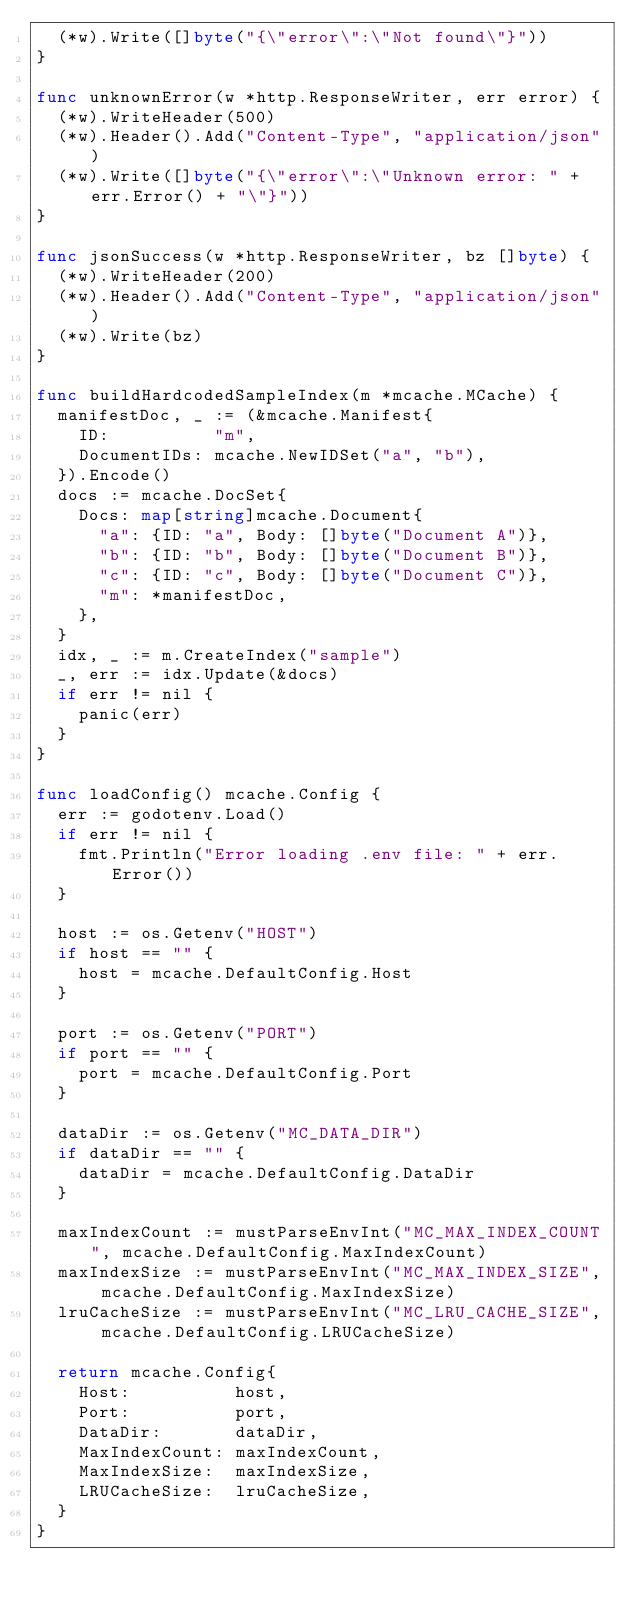<code> <loc_0><loc_0><loc_500><loc_500><_Go_>	(*w).Write([]byte("{\"error\":\"Not found\"}"))
}

func unknownError(w *http.ResponseWriter, err error) {
	(*w).WriteHeader(500)
	(*w).Header().Add("Content-Type", "application/json")
	(*w).Write([]byte("{\"error\":\"Unknown error: " + err.Error() + "\"}"))
}

func jsonSuccess(w *http.ResponseWriter, bz []byte) {
	(*w).WriteHeader(200)
	(*w).Header().Add("Content-Type", "application/json")
	(*w).Write(bz)
}

func buildHardcodedSampleIndex(m *mcache.MCache) {
	manifestDoc, _ := (&mcache.Manifest{
		ID:          "m",
		DocumentIDs: mcache.NewIDSet("a", "b"),
	}).Encode()
	docs := mcache.DocSet{
		Docs: map[string]mcache.Document{
			"a": {ID: "a", Body: []byte("Document A")},
			"b": {ID: "b", Body: []byte("Document B")},
			"c": {ID: "c", Body: []byte("Document C")},
			"m": *manifestDoc,
		},
	}
	idx, _ := m.CreateIndex("sample")
	_, err := idx.Update(&docs)
	if err != nil {
		panic(err)
	}
}

func loadConfig() mcache.Config {
	err := godotenv.Load()
	if err != nil {
		fmt.Println("Error loading .env file: " + err.Error())
	}

	host := os.Getenv("HOST")
	if host == "" {
		host = mcache.DefaultConfig.Host
	}

	port := os.Getenv("PORT")
	if port == "" {
		port = mcache.DefaultConfig.Port
	}

	dataDir := os.Getenv("MC_DATA_DIR")
	if dataDir == "" {
		dataDir = mcache.DefaultConfig.DataDir
	}

	maxIndexCount := mustParseEnvInt("MC_MAX_INDEX_COUNT", mcache.DefaultConfig.MaxIndexCount)
	maxIndexSize := mustParseEnvInt("MC_MAX_INDEX_SIZE", mcache.DefaultConfig.MaxIndexSize)
	lruCacheSize := mustParseEnvInt("MC_LRU_CACHE_SIZE", mcache.DefaultConfig.LRUCacheSize)

	return mcache.Config{
		Host:          host,
		Port:          port,
		DataDir:       dataDir,
		MaxIndexCount: maxIndexCount,
		MaxIndexSize:  maxIndexSize,
		LRUCacheSize:  lruCacheSize,
	}
}
</code> 